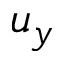Convert formula to latex. <formula><loc_0><loc_0><loc_500><loc_500>u _ { y }</formula> 